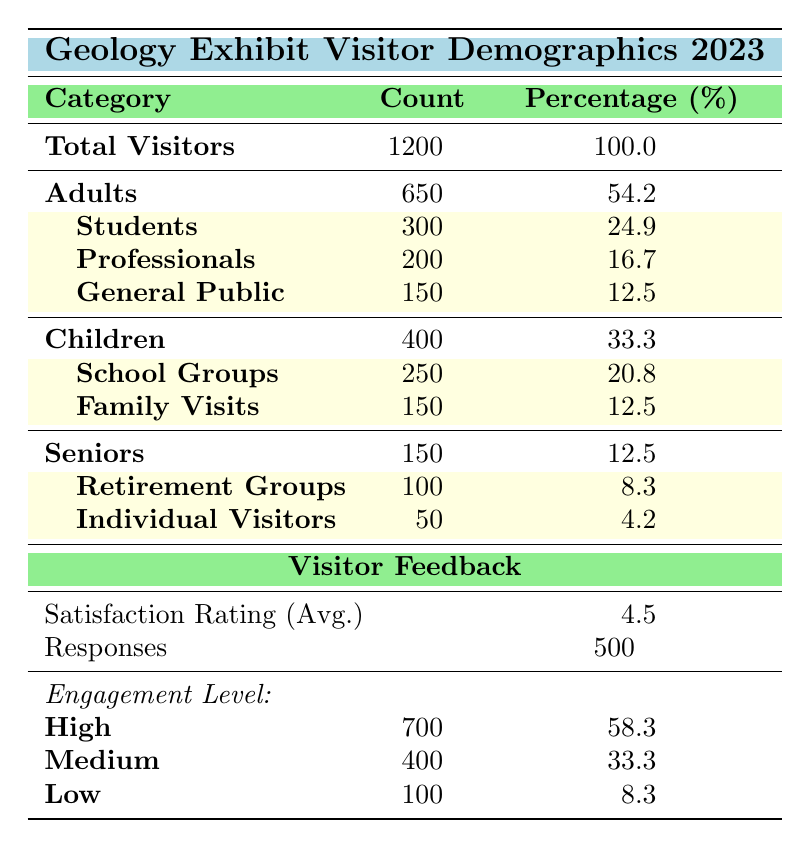What is the total number of visitors to the geology exhibit in 2023? The total number of visitors is provided in the "Total Visitors" row under the "Attendance" section of the table, which states 1200 visitors.
Answer: 1200 What percentage of attendees were children? The percentage of children is specified in the "Children" row under the "Attendance" section, listed as 33.3%.
Answer: 33.3% How many adults attended the exhibit in 2023? The table indicates that the number of adults is presented in the "Adults" row under the "Attendance" section, which shows a count of 650.
Answer: 650 What is the average satisfaction rating of the visitors? The average satisfaction rating is listed under the "Visitor Feedback" section as 4.5, clearly indicated in the row for "Satisfaction Rating (Avg.)."
Answer: 4.5 What percentage of total visitors were professionals? The professionals' count is found under the "Adults" category, where it indicates 200 professionals out of 1200 total visitors. To find the percentage, the formula is (200 / 1200) * 100, which equals approximately 16.7%.
Answer: 16.7% Is the number of children greater than the number of seniors? The count of children is 400, and the count of seniors is 150. Since 400 is greater than 150, this is true.
Answer: Yes What is the engagement level for medium visitors, and how does it compare to low engagement? The count for medium engagement is 400 and for low engagement is 100, which shows that medium engagement (400) is higher than low engagement (100).
Answer: Medium engagement is higher If we combine the counts of students and professionals, what percentage of total visitors does that represent? The count for students is 300 and for professionals is 200. Combined, that is 300 + 200 = 500. To find the percentage of total visitors, (500 / 1200) * 100 equals approximately 41.7%.
Answer: 41.7% What is the ratio of individuals in retirement groups to individual visitors among seniors? The retirement groups count is 100, and individual visitors count is 50. The ratio is 100:50, which simplifies to 2:1.
Answer: 2:1 How many visitors provided feedback for the exhibit? The number of responses for feedback is indicated in the "Visitor Feedback" section under the "Responses" row, which states there were 500 respondents.
Answer: 500 